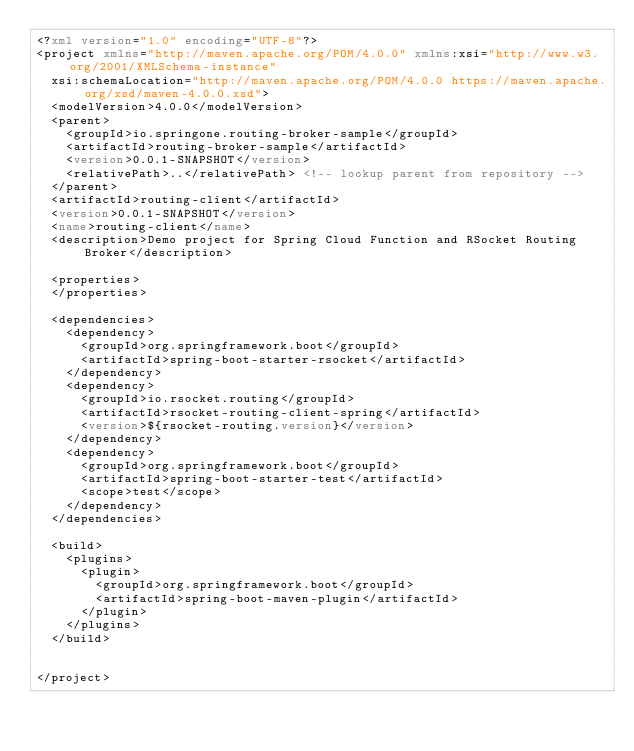Convert code to text. <code><loc_0><loc_0><loc_500><loc_500><_XML_><?xml version="1.0" encoding="UTF-8"?>
<project xmlns="http://maven.apache.org/POM/4.0.0" xmlns:xsi="http://www.w3.org/2001/XMLSchema-instance"
	xsi:schemaLocation="http://maven.apache.org/POM/4.0.0 https://maven.apache.org/xsd/maven-4.0.0.xsd">
	<modelVersion>4.0.0</modelVersion>
	<parent>
		<groupId>io.springone.routing-broker-sample</groupId>
		<artifactId>routing-broker-sample</artifactId>
		<version>0.0.1-SNAPSHOT</version>
		<relativePath>..</relativePath> <!-- lookup parent from repository -->
	</parent>
	<artifactId>routing-client</artifactId>
	<version>0.0.1-SNAPSHOT</version>
	<name>routing-client</name>
	<description>Demo project for Spring Cloud Function and RSocket Routing Broker</description>

	<properties>
	</properties>

	<dependencies>
		<dependency>
			<groupId>org.springframework.boot</groupId>
			<artifactId>spring-boot-starter-rsocket</artifactId>
		</dependency>
		<dependency>
			<groupId>io.rsocket.routing</groupId>
			<artifactId>rsocket-routing-client-spring</artifactId>
			<version>${rsocket-routing.version}</version>
		</dependency>
		<dependency>
			<groupId>org.springframework.boot</groupId>
			<artifactId>spring-boot-starter-test</artifactId>
			<scope>test</scope>
		</dependency>
	</dependencies>

	<build>
		<plugins>
			<plugin>
				<groupId>org.springframework.boot</groupId>
				<artifactId>spring-boot-maven-plugin</artifactId>
			</plugin>
		</plugins>
	</build>


</project>
</code> 